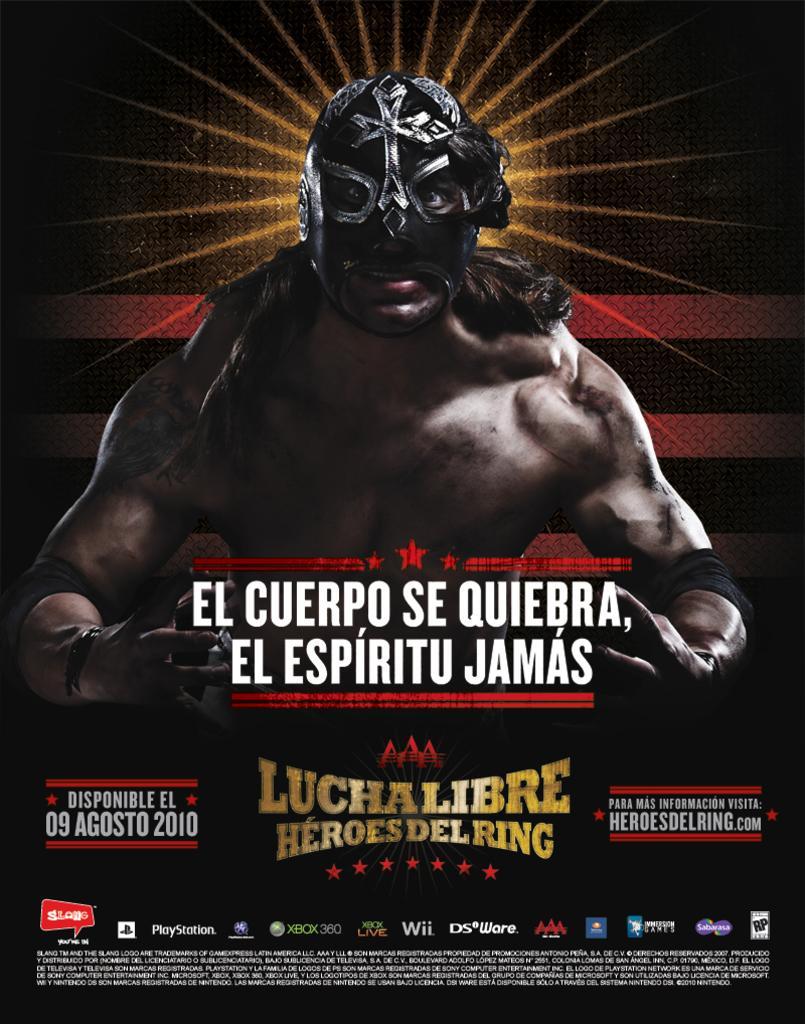Please provide a concise description of this image. This is a picture of a poster, where there is a person with a mask , and there are words , symbols and some icons on the poster. 